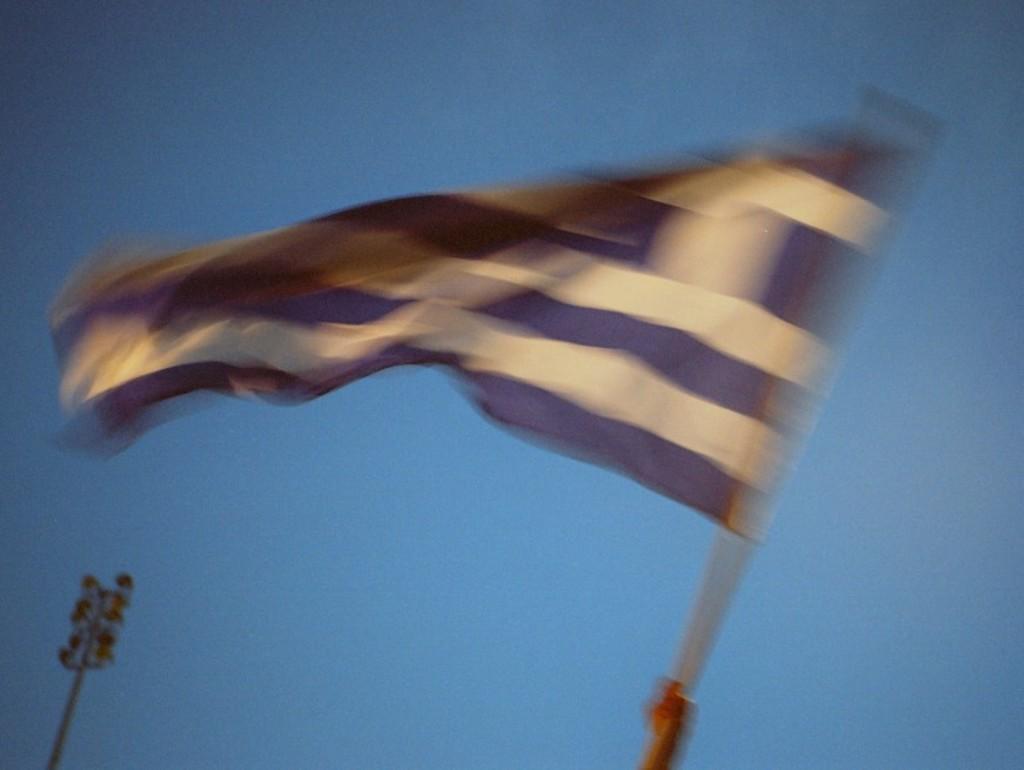Describe this image in one or two sentences. In this image, I can see a pole with a flag. I think it looks like a flood light. The background looks blue in color. 